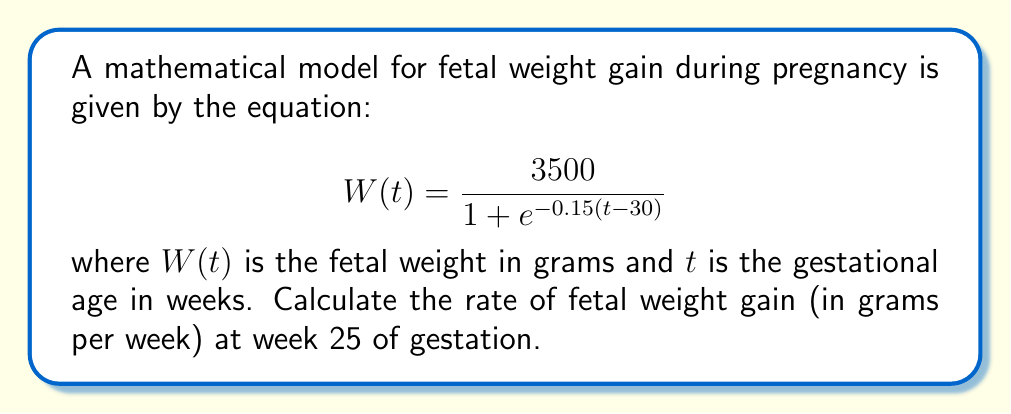Can you solve this math problem? To find the rate of fetal weight gain at week 25, we need to calculate the derivative of the weight function $W(t)$ and evaluate it at $t = 25$.

Step 1: Calculate the derivative of $W(t)$ using the chain rule.
$$\frac{dW}{dt} = \frac{3500 \cdot 0.15e^{-0.15(t-30)}}{(1 + e^{-0.15(t-30)})^2}$$

Step 2: Evaluate the derivative at $t = 25$.
$$\frac{dW}{dt}\bigg|_{t=25} = \frac{3500 \cdot 0.15e^{-0.15(25-30)}}{(1 + e^{-0.15(25-30)})^2}$$

Step 3: Simplify the expression.
$$\frac{dW}{dt}\bigg|_{t=25} = \frac{3500 \cdot 0.15e^{0.75}}{(1 + e^{0.75})^2}$$

Step 4: Calculate the numerical value.
$$\frac{dW}{dt}\bigg|_{t=25} \approx 131.25 \text{ grams/week}$$

This result indicates that at week 25 of gestation, the fetus is gaining approximately 131.25 grams per week according to this model.
Answer: 131.25 grams/week 